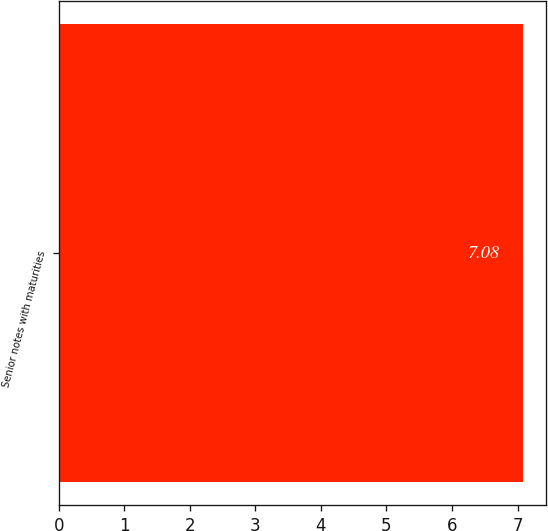Convert chart to OTSL. <chart><loc_0><loc_0><loc_500><loc_500><bar_chart><fcel>Senior notes with maturities<nl><fcel>7.08<nl></chart> 